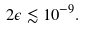Convert formula to latex. <formula><loc_0><loc_0><loc_500><loc_500>2 \epsilon \lesssim 1 0 ^ { - 9 } .</formula> 